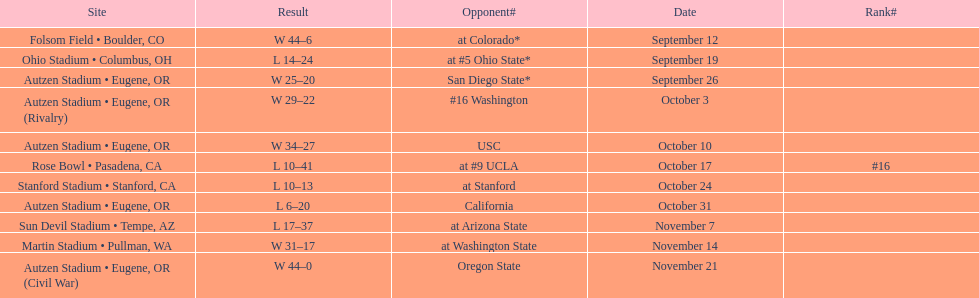Did the team win or lose more games? Win. I'm looking to parse the entire table for insights. Could you assist me with that? {'header': ['Site', 'Result', 'Opponent#', 'Date', 'Rank#'], 'rows': [['Folsom Field • Boulder, CO', 'W\xa044–6', 'at\xa0Colorado*', 'September 12', ''], ['Ohio Stadium • Columbus, OH', 'L\xa014–24', 'at\xa0#5\xa0Ohio State*', 'September 19', ''], ['Autzen Stadium • Eugene, OR', 'W\xa025–20', 'San Diego State*', 'September 26', ''], ['Autzen Stadium • Eugene, OR (Rivalry)', 'W\xa029–22', '#16\xa0Washington', 'October 3', ''], ['Autzen Stadium • Eugene, OR', 'W\xa034–27', 'USC', 'October 10', ''], ['Rose Bowl • Pasadena, CA', 'L\xa010–41', 'at\xa0#9\xa0UCLA', 'October 17', '#16'], ['Stanford Stadium • Stanford, CA', 'L\xa010–13', 'at\xa0Stanford', 'October 24', ''], ['Autzen Stadium • Eugene, OR', 'L\xa06–20', 'California', 'October 31', ''], ['Sun Devil Stadium • Tempe, AZ', 'L\xa017–37', 'at\xa0Arizona State', 'November 7', ''], ['Martin Stadium • Pullman, WA', 'W\xa031–17', 'at\xa0Washington State', 'November 14', ''], ['Autzen Stadium • Eugene, OR (Civil War)', 'W\xa044–0', 'Oregon State', 'November 21', '']]} 